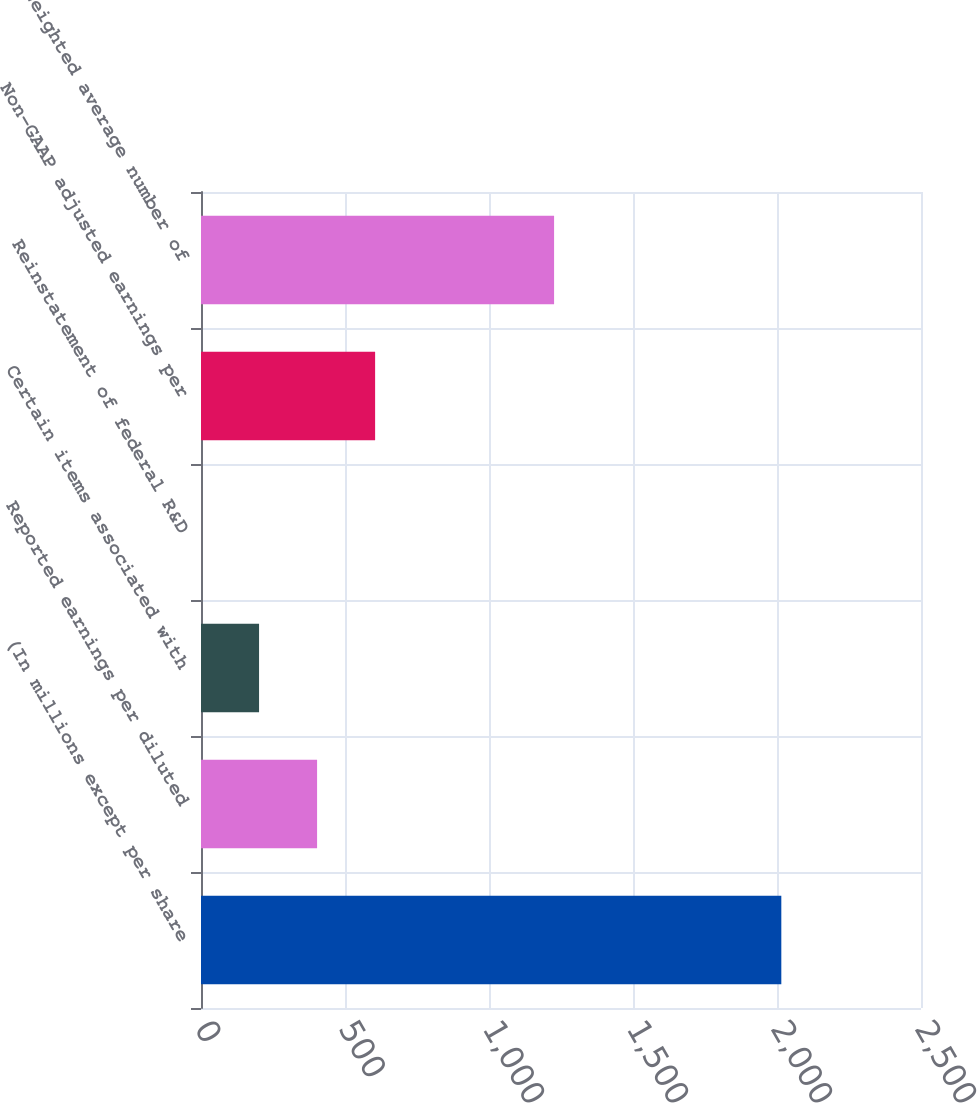Convert chart. <chart><loc_0><loc_0><loc_500><loc_500><bar_chart><fcel>(In millions except per share<fcel>Reported earnings per diluted<fcel>Certain items associated with<fcel>Reinstatement of federal R&D<fcel>Non-GAAP adjusted earnings per<fcel>Weighted average number of<nl><fcel>2015<fcel>403.07<fcel>201.58<fcel>0.09<fcel>604.56<fcel>1226<nl></chart> 